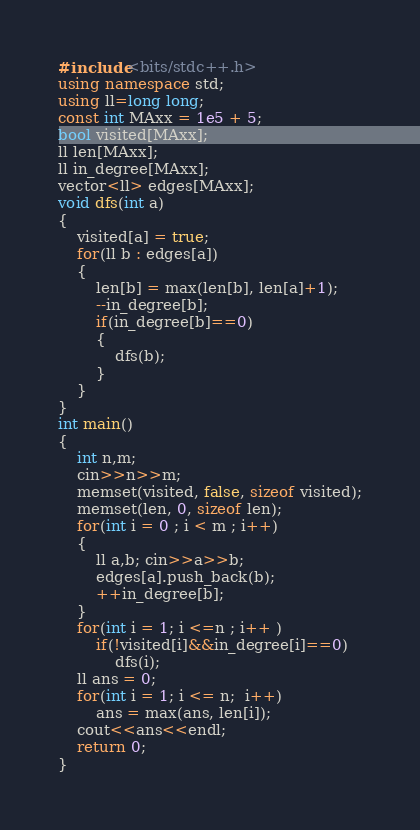<code> <loc_0><loc_0><loc_500><loc_500><_C++_>#include<bits/stdc++.h>
using namespace std;
using ll=long long;
const int MAxx = 1e5 + 5;
bool visited[MAxx];
ll len[MAxx];
ll in_degree[MAxx];
vector<ll> edges[MAxx];
void dfs(int a)
{
	visited[a] = true;
	for(ll b : edges[a])
	{
		len[b] = max(len[b], len[a]+1);
		--in_degree[b];
		if(in_degree[b]==0)
		{
			dfs(b);
		}
	}
}
int main()
{
	int n,m;
	cin>>n>>m;
	memset(visited, false, sizeof visited);
	memset(len, 0, sizeof len);
	for(int i = 0 ; i < m ; i++)
	{
		ll a,b; cin>>a>>b;
		edges[a].push_back(b);
		++in_degree[b];
	}
	for(int i = 1; i <=n ; i++ )
		if(!visited[i]&&in_degree[i]==0)
			dfs(i);
	ll ans = 0;
	for(int i = 1; i <= n;  i++)
		ans = max(ans, len[i]);
	cout<<ans<<endl;
	return 0;
}</code> 